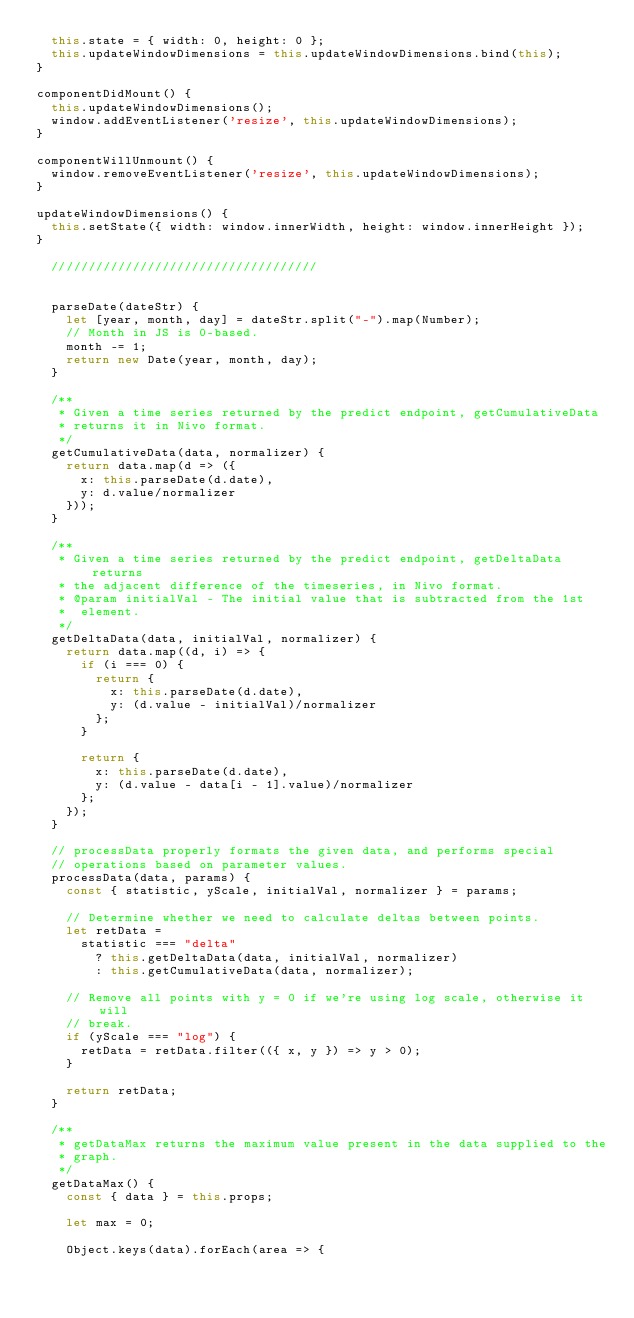<code> <loc_0><loc_0><loc_500><loc_500><_JavaScript_>  this.state = { width: 0, height: 0 };
  this.updateWindowDimensions = this.updateWindowDimensions.bind(this);
}

componentDidMount() {
  this.updateWindowDimensions();
  window.addEventListener('resize', this.updateWindowDimensions);
}

componentWillUnmount() {
  window.removeEventListener('resize', this.updateWindowDimensions);
}

updateWindowDimensions() {
  this.setState({ width: window.innerWidth, height: window.innerHeight });
}

  ////////////////////////////////////


  parseDate(dateStr) {
    let [year, month, day] = dateStr.split("-").map(Number);
    // Month in JS is 0-based.
    month -= 1;
    return new Date(year, month, day);
  }

  /**
   * Given a time series returned by the predict endpoint, getCumulativeData
   * returns it in Nivo format.
   */
  getCumulativeData(data, normalizer) {
    return data.map(d => ({
      x: this.parseDate(d.date),
      y: d.value/normalizer
    }));
  }

  /**
   * Given a time series returned by the predict endpoint, getDeltaData returns
   * the adjacent difference of the timeseries, in Nivo format.
   * @param initialVal - The initial value that is subtracted from the 1st
   *  element.
   */
  getDeltaData(data, initialVal, normalizer) {
    return data.map((d, i) => {
      if (i === 0) {
        return {
          x: this.parseDate(d.date),
          y: (d.value - initialVal)/normalizer
        };
      }

      return {
        x: this.parseDate(d.date),
        y: (d.value - data[i - 1].value)/normalizer
      };
    });
  }

  // processData properly formats the given data, and performs special
  // operations based on parameter values.
  processData(data, params) {
    const { statistic, yScale, initialVal, normalizer } = params;

    // Determine whether we need to calculate deltas between points.
    let retData =
      statistic === "delta"
        ? this.getDeltaData(data, initialVal, normalizer)
        : this.getCumulativeData(data, normalizer);

    // Remove all points with y = 0 if we're using log scale, otherwise it will
    // break.
    if (yScale === "log") {
      retData = retData.filter(({ x, y }) => y > 0);
    }

    return retData;
  }

  /**
   * getDataMax returns the maximum value present in the data supplied to the
   * graph.
   */
  getDataMax() {
    const { data } = this.props;

    let max = 0;

    Object.keys(data).forEach(area => {</code> 